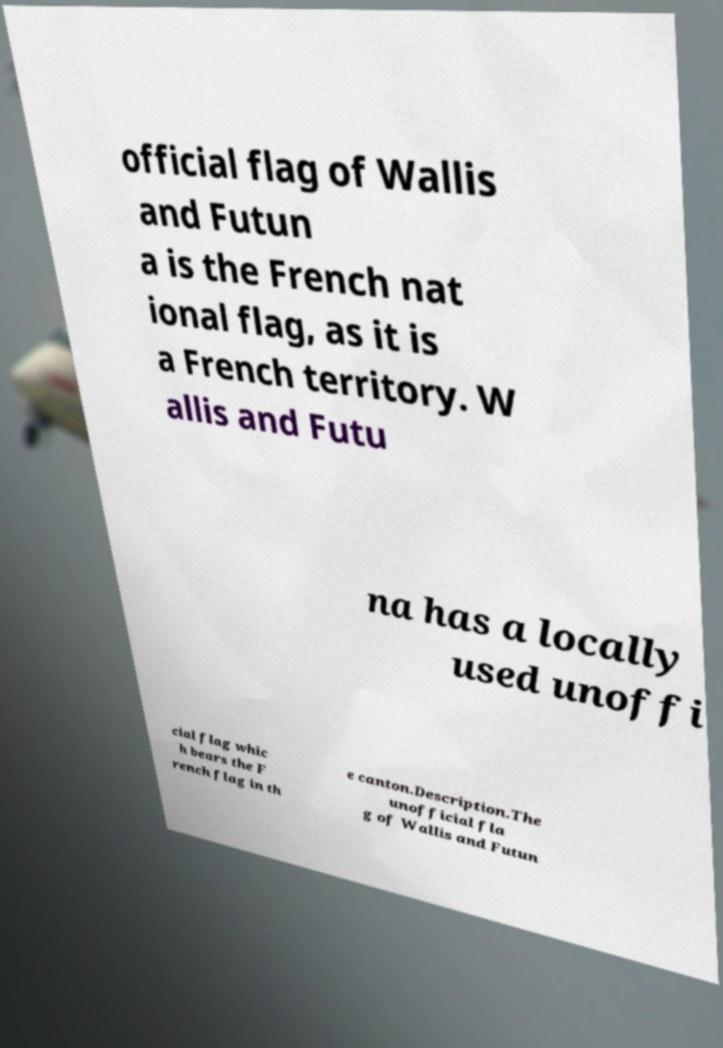Could you assist in decoding the text presented in this image and type it out clearly? official flag of Wallis and Futun a is the French nat ional flag, as it is a French territory. W allis and Futu na has a locally used unoffi cial flag whic h bears the F rench flag in th e canton.Description.The unofficial fla g of Wallis and Futun 